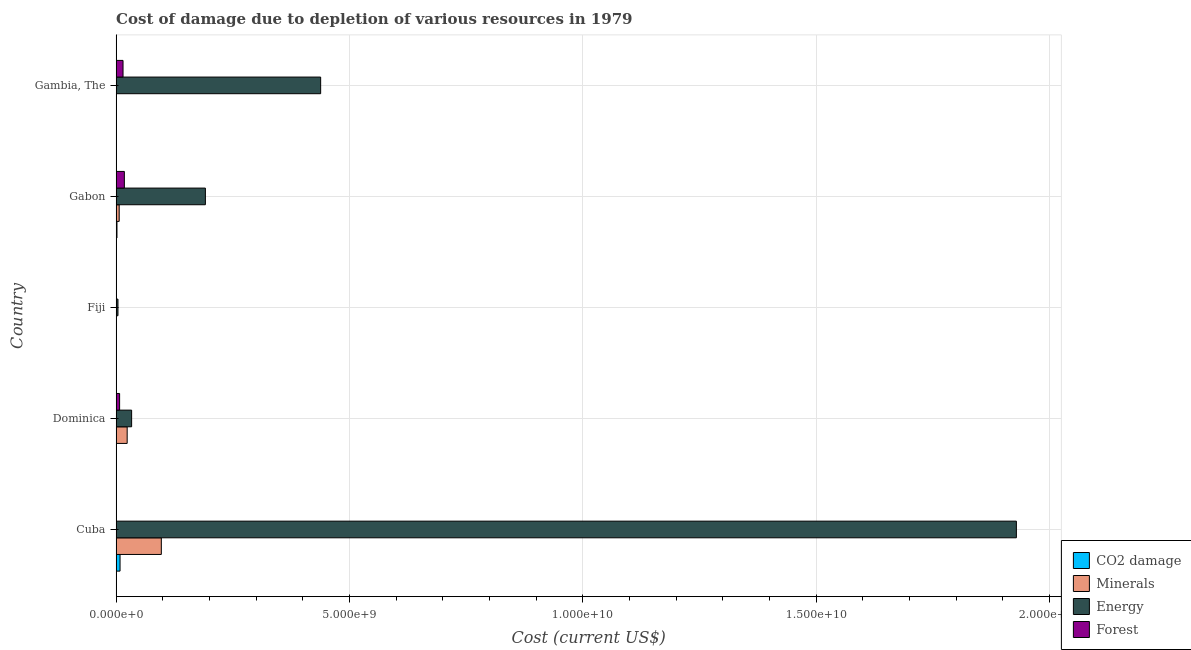How many different coloured bars are there?
Provide a short and direct response. 4. How many groups of bars are there?
Make the answer very short. 5. Are the number of bars per tick equal to the number of legend labels?
Keep it short and to the point. Yes. Are the number of bars on each tick of the Y-axis equal?
Offer a terse response. Yes. How many bars are there on the 4th tick from the bottom?
Provide a succinct answer. 4. What is the label of the 2nd group of bars from the top?
Provide a short and direct response. Gabon. What is the cost of damage due to depletion of energy in Gambia, The?
Keep it short and to the point. 4.38e+09. Across all countries, what is the maximum cost of damage due to depletion of energy?
Keep it short and to the point. 1.93e+1. Across all countries, what is the minimum cost of damage due to depletion of energy?
Offer a terse response. 3.92e+07. In which country was the cost of damage due to depletion of coal maximum?
Offer a very short reply. Cuba. In which country was the cost of damage due to depletion of coal minimum?
Keep it short and to the point. Dominica. What is the total cost of damage due to depletion of forests in the graph?
Give a very brief answer. 4.04e+08. What is the difference between the cost of damage due to depletion of energy in Gabon and that in Gambia, The?
Your response must be concise. -2.47e+09. What is the difference between the cost of damage due to depletion of forests in Gambia, The and the cost of damage due to depletion of minerals in Gabon?
Provide a succinct answer. 8.24e+07. What is the average cost of damage due to depletion of coal per country?
Make the answer very short. 2.09e+07. What is the difference between the cost of damage due to depletion of minerals and cost of damage due to depletion of coal in Gambia, The?
Offer a very short reply. 1.71e+05. In how many countries, is the cost of damage due to depletion of forests greater than 13000000000 US$?
Ensure brevity in your answer.  0. What is the ratio of the cost of damage due to depletion of energy in Dominica to that in Gambia, The?
Your answer should be very brief. 0.08. Is the difference between the cost of damage due to depletion of forests in Cuba and Gambia, The greater than the difference between the cost of damage due to depletion of energy in Cuba and Gambia, The?
Offer a very short reply. No. What is the difference between the highest and the second highest cost of damage due to depletion of forests?
Give a very brief answer. 2.82e+07. What is the difference between the highest and the lowest cost of damage due to depletion of coal?
Provide a succinct answer. 8.39e+07. What does the 1st bar from the top in Gambia, The represents?
Ensure brevity in your answer.  Forest. What does the 2nd bar from the bottom in Dominica represents?
Your answer should be very brief. Minerals. Is it the case that in every country, the sum of the cost of damage due to depletion of coal and cost of damage due to depletion of minerals is greater than the cost of damage due to depletion of energy?
Ensure brevity in your answer.  No. How many bars are there?
Provide a succinct answer. 20. How many countries are there in the graph?
Offer a very short reply. 5. What is the difference between two consecutive major ticks on the X-axis?
Provide a short and direct response. 5.00e+09. What is the title of the graph?
Offer a very short reply. Cost of damage due to depletion of various resources in 1979 . Does "Luxembourg" appear as one of the legend labels in the graph?
Make the answer very short. No. What is the label or title of the X-axis?
Ensure brevity in your answer.  Cost (current US$). What is the Cost (current US$) of CO2 damage in Cuba?
Provide a short and direct response. 8.40e+07. What is the Cost (current US$) of Minerals in Cuba?
Make the answer very short. 9.68e+08. What is the Cost (current US$) of Energy in Cuba?
Provide a short and direct response. 1.93e+1. What is the Cost (current US$) in Forest in Cuba?
Ensure brevity in your answer.  2.40e+05. What is the Cost (current US$) in CO2 damage in Dominica?
Ensure brevity in your answer.  8.74e+04. What is the Cost (current US$) in Minerals in Dominica?
Your answer should be very brief. 2.36e+08. What is the Cost (current US$) in Energy in Dominica?
Offer a very short reply. 3.32e+08. What is the Cost (current US$) of Forest in Dominica?
Provide a succinct answer. 7.46e+07. What is the Cost (current US$) in CO2 damage in Fiji?
Offer a very short reply. 2.22e+06. What is the Cost (current US$) of Minerals in Fiji?
Make the answer very short. 5.69e+06. What is the Cost (current US$) in Energy in Fiji?
Offer a terse response. 3.92e+07. What is the Cost (current US$) in Forest in Fiji?
Make the answer very short. 4.87e+06. What is the Cost (current US$) of CO2 damage in Gabon?
Offer a very short reply. 1.79e+07. What is the Cost (current US$) of Minerals in Gabon?
Keep it short and to the point. 6.56e+07. What is the Cost (current US$) in Energy in Gabon?
Your response must be concise. 1.91e+09. What is the Cost (current US$) of Forest in Gabon?
Make the answer very short. 1.76e+08. What is the Cost (current US$) of CO2 damage in Gambia, The?
Offer a terse response. 3.89e+05. What is the Cost (current US$) in Minerals in Gambia, The?
Your answer should be very brief. 5.59e+05. What is the Cost (current US$) in Energy in Gambia, The?
Your response must be concise. 4.38e+09. What is the Cost (current US$) of Forest in Gambia, The?
Your response must be concise. 1.48e+08. Across all countries, what is the maximum Cost (current US$) of CO2 damage?
Ensure brevity in your answer.  8.40e+07. Across all countries, what is the maximum Cost (current US$) in Minerals?
Offer a very short reply. 9.68e+08. Across all countries, what is the maximum Cost (current US$) of Energy?
Offer a very short reply. 1.93e+1. Across all countries, what is the maximum Cost (current US$) in Forest?
Your response must be concise. 1.76e+08. Across all countries, what is the minimum Cost (current US$) in CO2 damage?
Make the answer very short. 8.74e+04. Across all countries, what is the minimum Cost (current US$) of Minerals?
Your answer should be compact. 5.59e+05. Across all countries, what is the minimum Cost (current US$) in Energy?
Your answer should be very brief. 3.92e+07. Across all countries, what is the minimum Cost (current US$) of Forest?
Provide a short and direct response. 2.40e+05. What is the total Cost (current US$) in CO2 damage in the graph?
Offer a terse response. 1.05e+08. What is the total Cost (current US$) in Minerals in the graph?
Your response must be concise. 1.28e+09. What is the total Cost (current US$) in Energy in the graph?
Offer a terse response. 2.60e+1. What is the total Cost (current US$) of Forest in the graph?
Your answer should be compact. 4.04e+08. What is the difference between the Cost (current US$) in CO2 damage in Cuba and that in Dominica?
Your response must be concise. 8.39e+07. What is the difference between the Cost (current US$) in Minerals in Cuba and that in Dominica?
Give a very brief answer. 7.32e+08. What is the difference between the Cost (current US$) in Energy in Cuba and that in Dominica?
Provide a succinct answer. 1.90e+1. What is the difference between the Cost (current US$) of Forest in Cuba and that in Dominica?
Your response must be concise. -7.44e+07. What is the difference between the Cost (current US$) of CO2 damage in Cuba and that in Fiji?
Your response must be concise. 8.18e+07. What is the difference between the Cost (current US$) in Minerals in Cuba and that in Fiji?
Make the answer very short. 9.63e+08. What is the difference between the Cost (current US$) of Energy in Cuba and that in Fiji?
Ensure brevity in your answer.  1.93e+1. What is the difference between the Cost (current US$) of Forest in Cuba and that in Fiji?
Give a very brief answer. -4.63e+06. What is the difference between the Cost (current US$) of CO2 damage in Cuba and that in Gabon?
Your answer should be compact. 6.61e+07. What is the difference between the Cost (current US$) of Minerals in Cuba and that in Gabon?
Make the answer very short. 9.03e+08. What is the difference between the Cost (current US$) of Energy in Cuba and that in Gabon?
Provide a succinct answer. 1.74e+1. What is the difference between the Cost (current US$) in Forest in Cuba and that in Gabon?
Provide a succinct answer. -1.76e+08. What is the difference between the Cost (current US$) in CO2 damage in Cuba and that in Gambia, The?
Provide a short and direct response. 8.36e+07. What is the difference between the Cost (current US$) in Minerals in Cuba and that in Gambia, The?
Give a very brief answer. 9.68e+08. What is the difference between the Cost (current US$) of Energy in Cuba and that in Gambia, The?
Offer a terse response. 1.49e+1. What is the difference between the Cost (current US$) of Forest in Cuba and that in Gambia, The?
Provide a short and direct response. -1.48e+08. What is the difference between the Cost (current US$) in CO2 damage in Dominica and that in Fiji?
Offer a terse response. -2.14e+06. What is the difference between the Cost (current US$) in Minerals in Dominica and that in Fiji?
Offer a very short reply. 2.31e+08. What is the difference between the Cost (current US$) of Energy in Dominica and that in Fiji?
Ensure brevity in your answer.  2.93e+08. What is the difference between the Cost (current US$) in Forest in Dominica and that in Fiji?
Give a very brief answer. 6.98e+07. What is the difference between the Cost (current US$) of CO2 damage in Dominica and that in Gabon?
Ensure brevity in your answer.  -1.78e+07. What is the difference between the Cost (current US$) of Minerals in Dominica and that in Gabon?
Offer a very short reply. 1.71e+08. What is the difference between the Cost (current US$) in Energy in Dominica and that in Gabon?
Your answer should be very brief. -1.58e+09. What is the difference between the Cost (current US$) in Forest in Dominica and that in Gabon?
Keep it short and to the point. -1.02e+08. What is the difference between the Cost (current US$) in CO2 damage in Dominica and that in Gambia, The?
Make the answer very short. -3.01e+05. What is the difference between the Cost (current US$) in Minerals in Dominica and that in Gambia, The?
Give a very brief answer. 2.36e+08. What is the difference between the Cost (current US$) in Energy in Dominica and that in Gambia, The?
Ensure brevity in your answer.  -4.05e+09. What is the difference between the Cost (current US$) in Forest in Dominica and that in Gambia, The?
Offer a terse response. -7.33e+07. What is the difference between the Cost (current US$) in CO2 damage in Fiji and that in Gabon?
Your response must be concise. -1.57e+07. What is the difference between the Cost (current US$) in Minerals in Fiji and that in Gabon?
Your answer should be compact. -5.99e+07. What is the difference between the Cost (current US$) of Energy in Fiji and that in Gabon?
Offer a terse response. -1.87e+09. What is the difference between the Cost (current US$) in Forest in Fiji and that in Gabon?
Ensure brevity in your answer.  -1.71e+08. What is the difference between the Cost (current US$) of CO2 damage in Fiji and that in Gambia, The?
Your answer should be very brief. 1.84e+06. What is the difference between the Cost (current US$) of Minerals in Fiji and that in Gambia, The?
Your answer should be very brief. 5.13e+06. What is the difference between the Cost (current US$) of Energy in Fiji and that in Gambia, The?
Give a very brief answer. -4.34e+09. What is the difference between the Cost (current US$) of Forest in Fiji and that in Gambia, The?
Your answer should be very brief. -1.43e+08. What is the difference between the Cost (current US$) of CO2 damage in Gabon and that in Gambia, The?
Your answer should be compact. 1.75e+07. What is the difference between the Cost (current US$) of Minerals in Gabon and that in Gambia, The?
Your response must be concise. 6.51e+07. What is the difference between the Cost (current US$) in Energy in Gabon and that in Gambia, The?
Offer a terse response. -2.47e+09. What is the difference between the Cost (current US$) of Forest in Gabon and that in Gambia, The?
Offer a terse response. 2.82e+07. What is the difference between the Cost (current US$) in CO2 damage in Cuba and the Cost (current US$) in Minerals in Dominica?
Provide a short and direct response. -1.52e+08. What is the difference between the Cost (current US$) of CO2 damage in Cuba and the Cost (current US$) of Energy in Dominica?
Your answer should be compact. -2.48e+08. What is the difference between the Cost (current US$) of CO2 damage in Cuba and the Cost (current US$) of Forest in Dominica?
Keep it short and to the point. 9.37e+06. What is the difference between the Cost (current US$) in Minerals in Cuba and the Cost (current US$) in Energy in Dominica?
Give a very brief answer. 6.37e+08. What is the difference between the Cost (current US$) in Minerals in Cuba and the Cost (current US$) in Forest in Dominica?
Make the answer very short. 8.94e+08. What is the difference between the Cost (current US$) in Energy in Cuba and the Cost (current US$) in Forest in Dominica?
Make the answer very short. 1.92e+1. What is the difference between the Cost (current US$) of CO2 damage in Cuba and the Cost (current US$) of Minerals in Fiji?
Your answer should be very brief. 7.83e+07. What is the difference between the Cost (current US$) in CO2 damage in Cuba and the Cost (current US$) in Energy in Fiji?
Make the answer very short. 4.48e+07. What is the difference between the Cost (current US$) in CO2 damage in Cuba and the Cost (current US$) in Forest in Fiji?
Keep it short and to the point. 7.91e+07. What is the difference between the Cost (current US$) in Minerals in Cuba and the Cost (current US$) in Energy in Fiji?
Make the answer very short. 9.29e+08. What is the difference between the Cost (current US$) in Minerals in Cuba and the Cost (current US$) in Forest in Fiji?
Keep it short and to the point. 9.64e+08. What is the difference between the Cost (current US$) in Energy in Cuba and the Cost (current US$) in Forest in Fiji?
Keep it short and to the point. 1.93e+1. What is the difference between the Cost (current US$) in CO2 damage in Cuba and the Cost (current US$) in Minerals in Gabon?
Your response must be concise. 1.84e+07. What is the difference between the Cost (current US$) in CO2 damage in Cuba and the Cost (current US$) in Energy in Gabon?
Ensure brevity in your answer.  -1.83e+09. What is the difference between the Cost (current US$) in CO2 damage in Cuba and the Cost (current US$) in Forest in Gabon?
Provide a succinct answer. -9.22e+07. What is the difference between the Cost (current US$) in Minerals in Cuba and the Cost (current US$) in Energy in Gabon?
Provide a short and direct response. -9.44e+08. What is the difference between the Cost (current US$) of Minerals in Cuba and the Cost (current US$) of Forest in Gabon?
Ensure brevity in your answer.  7.92e+08. What is the difference between the Cost (current US$) of Energy in Cuba and the Cost (current US$) of Forest in Gabon?
Offer a terse response. 1.91e+1. What is the difference between the Cost (current US$) of CO2 damage in Cuba and the Cost (current US$) of Minerals in Gambia, The?
Offer a terse response. 8.34e+07. What is the difference between the Cost (current US$) in CO2 damage in Cuba and the Cost (current US$) in Energy in Gambia, The?
Your response must be concise. -4.30e+09. What is the difference between the Cost (current US$) of CO2 damage in Cuba and the Cost (current US$) of Forest in Gambia, The?
Your answer should be compact. -6.40e+07. What is the difference between the Cost (current US$) of Minerals in Cuba and the Cost (current US$) of Energy in Gambia, The?
Provide a short and direct response. -3.41e+09. What is the difference between the Cost (current US$) in Minerals in Cuba and the Cost (current US$) in Forest in Gambia, The?
Provide a short and direct response. 8.20e+08. What is the difference between the Cost (current US$) of Energy in Cuba and the Cost (current US$) of Forest in Gambia, The?
Provide a succinct answer. 1.91e+1. What is the difference between the Cost (current US$) in CO2 damage in Dominica and the Cost (current US$) in Minerals in Fiji?
Provide a succinct answer. -5.60e+06. What is the difference between the Cost (current US$) of CO2 damage in Dominica and the Cost (current US$) of Energy in Fiji?
Your answer should be very brief. -3.92e+07. What is the difference between the Cost (current US$) of CO2 damage in Dominica and the Cost (current US$) of Forest in Fiji?
Offer a very short reply. -4.78e+06. What is the difference between the Cost (current US$) of Minerals in Dominica and the Cost (current US$) of Energy in Fiji?
Your answer should be very brief. 1.97e+08. What is the difference between the Cost (current US$) in Minerals in Dominica and the Cost (current US$) in Forest in Fiji?
Provide a short and direct response. 2.32e+08. What is the difference between the Cost (current US$) in Energy in Dominica and the Cost (current US$) in Forest in Fiji?
Your response must be concise. 3.27e+08. What is the difference between the Cost (current US$) in CO2 damage in Dominica and the Cost (current US$) in Minerals in Gabon?
Keep it short and to the point. -6.55e+07. What is the difference between the Cost (current US$) of CO2 damage in Dominica and the Cost (current US$) of Energy in Gabon?
Give a very brief answer. -1.91e+09. What is the difference between the Cost (current US$) of CO2 damage in Dominica and the Cost (current US$) of Forest in Gabon?
Your answer should be very brief. -1.76e+08. What is the difference between the Cost (current US$) in Minerals in Dominica and the Cost (current US$) in Energy in Gabon?
Ensure brevity in your answer.  -1.68e+09. What is the difference between the Cost (current US$) of Minerals in Dominica and the Cost (current US$) of Forest in Gabon?
Provide a short and direct response. 6.02e+07. What is the difference between the Cost (current US$) of Energy in Dominica and the Cost (current US$) of Forest in Gabon?
Your response must be concise. 1.56e+08. What is the difference between the Cost (current US$) of CO2 damage in Dominica and the Cost (current US$) of Minerals in Gambia, The?
Ensure brevity in your answer.  -4.72e+05. What is the difference between the Cost (current US$) of CO2 damage in Dominica and the Cost (current US$) of Energy in Gambia, The?
Offer a terse response. -4.38e+09. What is the difference between the Cost (current US$) in CO2 damage in Dominica and the Cost (current US$) in Forest in Gambia, The?
Your answer should be compact. -1.48e+08. What is the difference between the Cost (current US$) of Minerals in Dominica and the Cost (current US$) of Energy in Gambia, The?
Keep it short and to the point. -4.15e+09. What is the difference between the Cost (current US$) in Minerals in Dominica and the Cost (current US$) in Forest in Gambia, The?
Provide a succinct answer. 8.85e+07. What is the difference between the Cost (current US$) in Energy in Dominica and the Cost (current US$) in Forest in Gambia, The?
Offer a terse response. 1.84e+08. What is the difference between the Cost (current US$) of CO2 damage in Fiji and the Cost (current US$) of Minerals in Gabon?
Make the answer very short. -6.34e+07. What is the difference between the Cost (current US$) in CO2 damage in Fiji and the Cost (current US$) in Energy in Gabon?
Provide a short and direct response. -1.91e+09. What is the difference between the Cost (current US$) of CO2 damage in Fiji and the Cost (current US$) of Forest in Gabon?
Offer a terse response. -1.74e+08. What is the difference between the Cost (current US$) of Minerals in Fiji and the Cost (current US$) of Energy in Gabon?
Keep it short and to the point. -1.91e+09. What is the difference between the Cost (current US$) in Minerals in Fiji and the Cost (current US$) in Forest in Gabon?
Your response must be concise. -1.71e+08. What is the difference between the Cost (current US$) in Energy in Fiji and the Cost (current US$) in Forest in Gabon?
Provide a succinct answer. -1.37e+08. What is the difference between the Cost (current US$) of CO2 damage in Fiji and the Cost (current US$) of Minerals in Gambia, The?
Offer a terse response. 1.67e+06. What is the difference between the Cost (current US$) of CO2 damage in Fiji and the Cost (current US$) of Energy in Gambia, The?
Offer a very short reply. -4.38e+09. What is the difference between the Cost (current US$) in CO2 damage in Fiji and the Cost (current US$) in Forest in Gambia, The?
Offer a terse response. -1.46e+08. What is the difference between the Cost (current US$) of Minerals in Fiji and the Cost (current US$) of Energy in Gambia, The?
Offer a terse response. -4.38e+09. What is the difference between the Cost (current US$) of Minerals in Fiji and the Cost (current US$) of Forest in Gambia, The?
Offer a very short reply. -1.42e+08. What is the difference between the Cost (current US$) of Energy in Fiji and the Cost (current US$) of Forest in Gambia, The?
Give a very brief answer. -1.09e+08. What is the difference between the Cost (current US$) of CO2 damage in Gabon and the Cost (current US$) of Minerals in Gambia, The?
Your answer should be compact. 1.73e+07. What is the difference between the Cost (current US$) in CO2 damage in Gabon and the Cost (current US$) in Energy in Gambia, The?
Give a very brief answer. -4.37e+09. What is the difference between the Cost (current US$) in CO2 damage in Gabon and the Cost (current US$) in Forest in Gambia, The?
Provide a succinct answer. -1.30e+08. What is the difference between the Cost (current US$) of Minerals in Gabon and the Cost (current US$) of Energy in Gambia, The?
Provide a short and direct response. -4.32e+09. What is the difference between the Cost (current US$) of Minerals in Gabon and the Cost (current US$) of Forest in Gambia, The?
Ensure brevity in your answer.  -8.24e+07. What is the difference between the Cost (current US$) in Energy in Gabon and the Cost (current US$) in Forest in Gambia, The?
Ensure brevity in your answer.  1.76e+09. What is the average Cost (current US$) in CO2 damage per country?
Keep it short and to the point. 2.09e+07. What is the average Cost (current US$) in Minerals per country?
Ensure brevity in your answer.  2.55e+08. What is the average Cost (current US$) in Energy per country?
Give a very brief answer. 5.19e+09. What is the average Cost (current US$) of Forest per country?
Ensure brevity in your answer.  8.08e+07. What is the difference between the Cost (current US$) of CO2 damage and Cost (current US$) of Minerals in Cuba?
Offer a very short reply. -8.84e+08. What is the difference between the Cost (current US$) in CO2 damage and Cost (current US$) in Energy in Cuba?
Provide a short and direct response. -1.92e+1. What is the difference between the Cost (current US$) of CO2 damage and Cost (current US$) of Forest in Cuba?
Make the answer very short. 8.38e+07. What is the difference between the Cost (current US$) of Minerals and Cost (current US$) of Energy in Cuba?
Keep it short and to the point. -1.83e+1. What is the difference between the Cost (current US$) in Minerals and Cost (current US$) in Forest in Cuba?
Offer a terse response. 9.68e+08. What is the difference between the Cost (current US$) in Energy and Cost (current US$) in Forest in Cuba?
Give a very brief answer. 1.93e+1. What is the difference between the Cost (current US$) of CO2 damage and Cost (current US$) of Minerals in Dominica?
Your answer should be compact. -2.36e+08. What is the difference between the Cost (current US$) in CO2 damage and Cost (current US$) in Energy in Dominica?
Keep it short and to the point. -3.32e+08. What is the difference between the Cost (current US$) in CO2 damage and Cost (current US$) in Forest in Dominica?
Your answer should be compact. -7.46e+07. What is the difference between the Cost (current US$) of Minerals and Cost (current US$) of Energy in Dominica?
Ensure brevity in your answer.  -9.54e+07. What is the difference between the Cost (current US$) in Minerals and Cost (current US$) in Forest in Dominica?
Make the answer very short. 1.62e+08. What is the difference between the Cost (current US$) in Energy and Cost (current US$) in Forest in Dominica?
Your answer should be compact. 2.57e+08. What is the difference between the Cost (current US$) in CO2 damage and Cost (current US$) in Minerals in Fiji?
Give a very brief answer. -3.46e+06. What is the difference between the Cost (current US$) in CO2 damage and Cost (current US$) in Energy in Fiji?
Your response must be concise. -3.70e+07. What is the difference between the Cost (current US$) in CO2 damage and Cost (current US$) in Forest in Fiji?
Offer a terse response. -2.65e+06. What is the difference between the Cost (current US$) in Minerals and Cost (current US$) in Energy in Fiji?
Provide a short and direct response. -3.36e+07. What is the difference between the Cost (current US$) of Minerals and Cost (current US$) of Forest in Fiji?
Offer a terse response. 8.19e+05. What is the difference between the Cost (current US$) in Energy and Cost (current US$) in Forest in Fiji?
Your answer should be compact. 3.44e+07. What is the difference between the Cost (current US$) in CO2 damage and Cost (current US$) in Minerals in Gabon?
Your answer should be very brief. -4.77e+07. What is the difference between the Cost (current US$) of CO2 damage and Cost (current US$) of Energy in Gabon?
Offer a very short reply. -1.89e+09. What is the difference between the Cost (current US$) in CO2 damage and Cost (current US$) in Forest in Gabon?
Provide a short and direct response. -1.58e+08. What is the difference between the Cost (current US$) in Minerals and Cost (current US$) in Energy in Gabon?
Your answer should be compact. -1.85e+09. What is the difference between the Cost (current US$) of Minerals and Cost (current US$) of Forest in Gabon?
Your response must be concise. -1.11e+08. What is the difference between the Cost (current US$) of Energy and Cost (current US$) of Forest in Gabon?
Offer a terse response. 1.74e+09. What is the difference between the Cost (current US$) in CO2 damage and Cost (current US$) in Minerals in Gambia, The?
Provide a succinct answer. -1.71e+05. What is the difference between the Cost (current US$) in CO2 damage and Cost (current US$) in Energy in Gambia, The?
Give a very brief answer. -4.38e+09. What is the difference between the Cost (current US$) of CO2 damage and Cost (current US$) of Forest in Gambia, The?
Offer a very short reply. -1.48e+08. What is the difference between the Cost (current US$) of Minerals and Cost (current US$) of Energy in Gambia, The?
Make the answer very short. -4.38e+09. What is the difference between the Cost (current US$) of Minerals and Cost (current US$) of Forest in Gambia, The?
Provide a succinct answer. -1.47e+08. What is the difference between the Cost (current US$) in Energy and Cost (current US$) in Forest in Gambia, The?
Keep it short and to the point. 4.23e+09. What is the ratio of the Cost (current US$) of CO2 damage in Cuba to that in Dominica?
Offer a very short reply. 960.89. What is the ratio of the Cost (current US$) in Minerals in Cuba to that in Dominica?
Your answer should be compact. 4.1. What is the ratio of the Cost (current US$) of Energy in Cuba to that in Dominica?
Offer a very short reply. 58.12. What is the ratio of the Cost (current US$) of Forest in Cuba to that in Dominica?
Give a very brief answer. 0. What is the ratio of the Cost (current US$) of CO2 damage in Cuba to that in Fiji?
Provide a short and direct response. 37.76. What is the ratio of the Cost (current US$) in Minerals in Cuba to that in Fiji?
Your answer should be very brief. 170.26. What is the ratio of the Cost (current US$) in Energy in Cuba to that in Fiji?
Provide a succinct answer. 491.63. What is the ratio of the Cost (current US$) in Forest in Cuba to that in Fiji?
Give a very brief answer. 0.05. What is the ratio of the Cost (current US$) in CO2 damage in Cuba to that in Gabon?
Provide a short and direct response. 4.69. What is the ratio of the Cost (current US$) of Minerals in Cuba to that in Gabon?
Give a very brief answer. 14.76. What is the ratio of the Cost (current US$) in Energy in Cuba to that in Gabon?
Your response must be concise. 10.09. What is the ratio of the Cost (current US$) of Forest in Cuba to that in Gabon?
Give a very brief answer. 0. What is the ratio of the Cost (current US$) in CO2 damage in Cuba to that in Gambia, The?
Offer a terse response. 216.2. What is the ratio of the Cost (current US$) in Minerals in Cuba to that in Gambia, The?
Offer a very short reply. 1731.77. What is the ratio of the Cost (current US$) of Energy in Cuba to that in Gambia, The?
Provide a short and direct response. 4.4. What is the ratio of the Cost (current US$) of Forest in Cuba to that in Gambia, The?
Your answer should be very brief. 0. What is the ratio of the Cost (current US$) in CO2 damage in Dominica to that in Fiji?
Ensure brevity in your answer.  0.04. What is the ratio of the Cost (current US$) of Minerals in Dominica to that in Fiji?
Keep it short and to the point. 41.57. What is the ratio of the Cost (current US$) in Energy in Dominica to that in Fiji?
Provide a short and direct response. 8.46. What is the ratio of the Cost (current US$) in Forest in Dominica to that in Fiji?
Your response must be concise. 15.33. What is the ratio of the Cost (current US$) of CO2 damage in Dominica to that in Gabon?
Keep it short and to the point. 0. What is the ratio of the Cost (current US$) of Minerals in Dominica to that in Gabon?
Your response must be concise. 3.6. What is the ratio of the Cost (current US$) of Energy in Dominica to that in Gabon?
Keep it short and to the point. 0.17. What is the ratio of the Cost (current US$) of Forest in Dominica to that in Gabon?
Your response must be concise. 0.42. What is the ratio of the Cost (current US$) in CO2 damage in Dominica to that in Gambia, The?
Offer a terse response. 0.23. What is the ratio of the Cost (current US$) in Minerals in Dominica to that in Gambia, The?
Make the answer very short. 422.83. What is the ratio of the Cost (current US$) of Energy in Dominica to that in Gambia, The?
Give a very brief answer. 0.08. What is the ratio of the Cost (current US$) of Forest in Dominica to that in Gambia, The?
Offer a terse response. 0.5. What is the ratio of the Cost (current US$) in CO2 damage in Fiji to that in Gabon?
Your response must be concise. 0.12. What is the ratio of the Cost (current US$) in Minerals in Fiji to that in Gabon?
Offer a very short reply. 0.09. What is the ratio of the Cost (current US$) of Energy in Fiji to that in Gabon?
Keep it short and to the point. 0.02. What is the ratio of the Cost (current US$) in Forest in Fiji to that in Gabon?
Provide a succinct answer. 0.03. What is the ratio of the Cost (current US$) of CO2 damage in Fiji to that in Gambia, The?
Your answer should be compact. 5.72. What is the ratio of the Cost (current US$) of Minerals in Fiji to that in Gambia, The?
Provide a succinct answer. 10.17. What is the ratio of the Cost (current US$) in Energy in Fiji to that in Gambia, The?
Offer a terse response. 0.01. What is the ratio of the Cost (current US$) in Forest in Fiji to that in Gambia, The?
Provide a succinct answer. 0.03. What is the ratio of the Cost (current US$) in CO2 damage in Gabon to that in Gambia, The?
Provide a short and direct response. 46.05. What is the ratio of the Cost (current US$) of Minerals in Gabon to that in Gambia, The?
Provide a short and direct response. 117.33. What is the ratio of the Cost (current US$) of Energy in Gabon to that in Gambia, The?
Offer a terse response. 0.44. What is the ratio of the Cost (current US$) of Forest in Gabon to that in Gambia, The?
Give a very brief answer. 1.19. What is the difference between the highest and the second highest Cost (current US$) of CO2 damage?
Offer a very short reply. 6.61e+07. What is the difference between the highest and the second highest Cost (current US$) in Minerals?
Give a very brief answer. 7.32e+08. What is the difference between the highest and the second highest Cost (current US$) in Energy?
Provide a succinct answer. 1.49e+1. What is the difference between the highest and the second highest Cost (current US$) in Forest?
Offer a very short reply. 2.82e+07. What is the difference between the highest and the lowest Cost (current US$) in CO2 damage?
Make the answer very short. 8.39e+07. What is the difference between the highest and the lowest Cost (current US$) of Minerals?
Ensure brevity in your answer.  9.68e+08. What is the difference between the highest and the lowest Cost (current US$) in Energy?
Keep it short and to the point. 1.93e+1. What is the difference between the highest and the lowest Cost (current US$) of Forest?
Ensure brevity in your answer.  1.76e+08. 